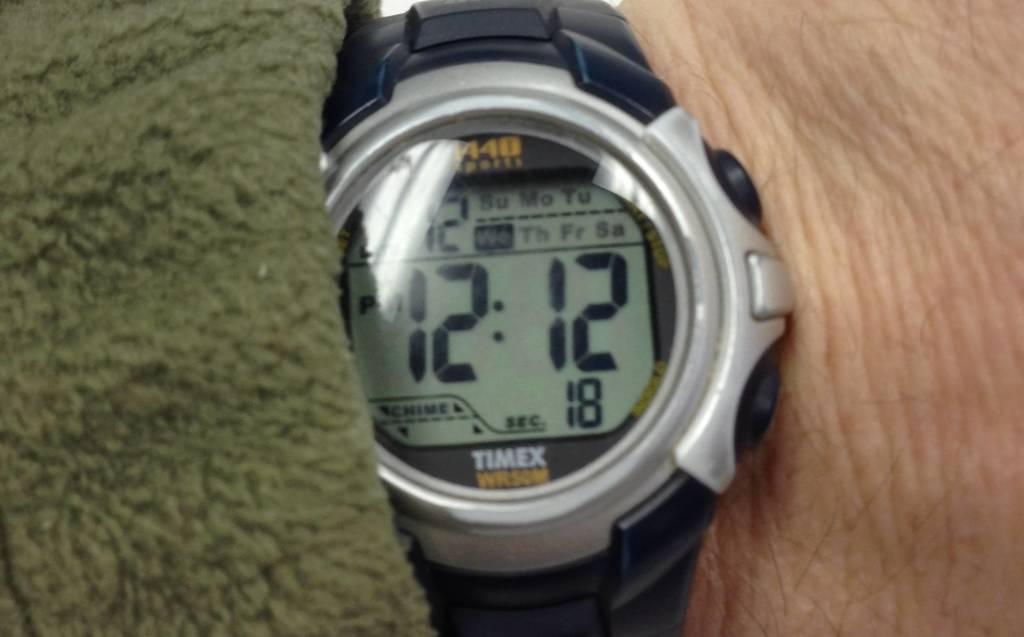What type of watch is that?
Provide a succinct answer. Timex. What time is displayed?
Offer a terse response. 12:12. 